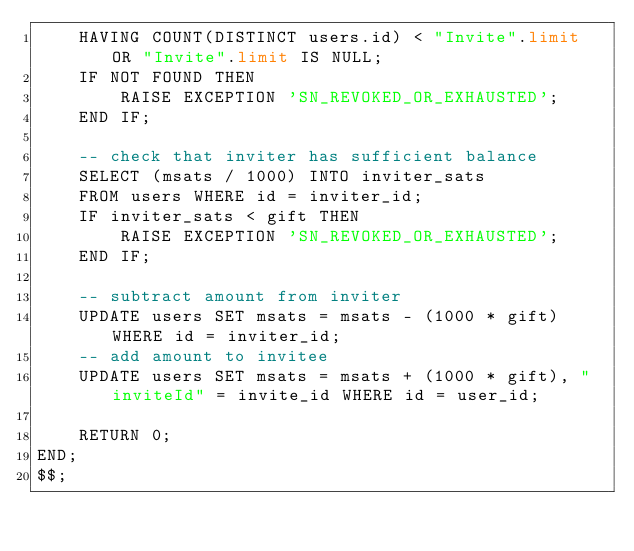<code> <loc_0><loc_0><loc_500><loc_500><_SQL_>    HAVING COUNT(DISTINCT users.id) < "Invite".limit OR "Invite".limit IS NULL;
    IF NOT FOUND THEN
        RAISE EXCEPTION 'SN_REVOKED_OR_EXHAUSTED';
    END IF;

    -- check that inviter has sufficient balance
    SELECT (msats / 1000) INTO inviter_sats
    FROM users WHERE id = inviter_id;
    IF inviter_sats < gift THEN
        RAISE EXCEPTION 'SN_REVOKED_OR_EXHAUSTED';
    END IF;

    -- subtract amount from inviter
    UPDATE users SET msats = msats - (1000 * gift) WHERE id = inviter_id;
    -- add amount to invitee
    UPDATE users SET msats = msats + (1000 * gift), "inviteId" = invite_id WHERE id = user_id;

    RETURN 0;
END;
$$;</code> 